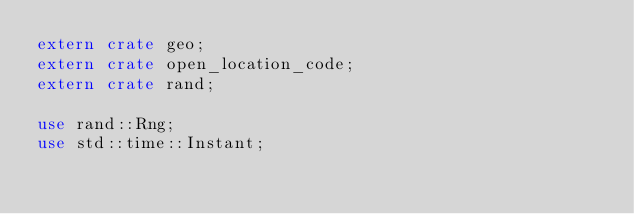Convert code to text. <code><loc_0><loc_0><loc_500><loc_500><_Rust_>extern crate geo;
extern crate open_location_code;
extern crate rand;

use rand::Rng;
use std::time::Instant;</code> 